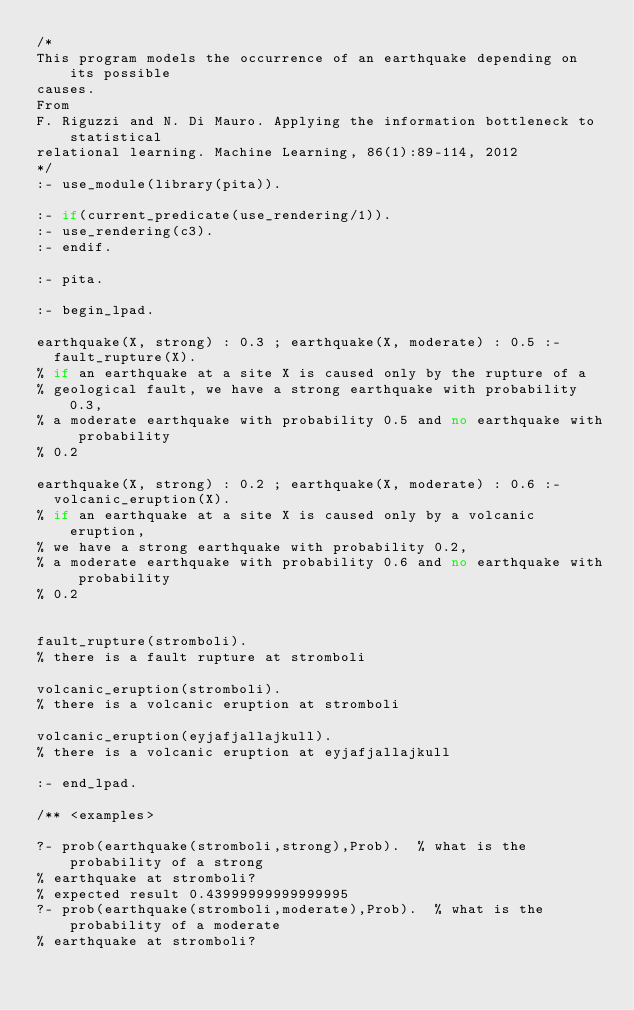Convert code to text. <code><loc_0><loc_0><loc_500><loc_500><_Perl_>/*
This program models the occurrence of an earthquake depending on its possible 
causes.
From
F. Riguzzi and N. Di Mauro. Applying the information bottleneck to statistical 
relational learning. Machine Learning, 86(1):89-114, 2012
*/
:- use_module(library(pita)).

:- if(current_predicate(use_rendering/1)).
:- use_rendering(c3).
:- endif.

:- pita.

:- begin_lpad.

earthquake(X, strong) : 0.3 ; earthquake(X, moderate) : 0.5 :-
  fault_rupture(X).
% if an earthquake at a site X is caused only by the rupture of a 
% geological fault, we have a strong earthquake with probability 0.3, 
% a moderate earthquake with probability 0.5 and no earthquake with probability 
% 0.2

earthquake(X, strong) : 0.2 ; earthquake(X, moderate) : 0.6 :-
  volcanic_eruption(X).
% if an earthquake at a site X is caused only by a volcanic eruption, 
% we have a strong earthquake with probability 0.2, 
% a moderate earthquake with probability 0.6 and no earthquake with probability 
% 0.2


fault_rupture(stromboli).
% there is a fault rupture at stromboli

volcanic_eruption(stromboli).
% there is a volcanic eruption at stromboli

volcanic_eruption(eyjafjallajkull).
% there is a volcanic eruption at eyjafjallajkull

:- end_lpad.

/** <examples>

?- prob(earthquake(stromboli,strong),Prob).  % what is the probability of a strong 
% earthquake at stromboli?
% expected result 0.43999999999999995
?- prob(earthquake(stromboli,moderate),Prob).  % what is the probability of a moderate
% earthquake at stromboli?</code> 